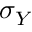<formula> <loc_0><loc_0><loc_500><loc_500>\sigma _ { Y }</formula> 